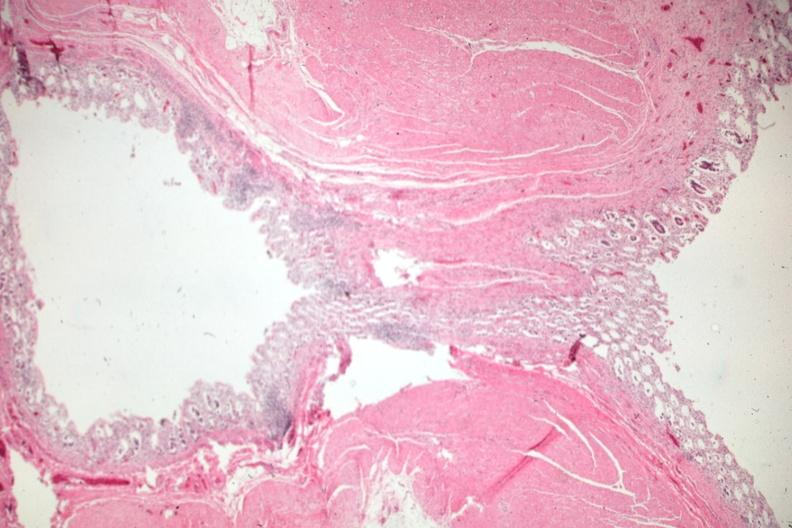does this image show exceptional view of an uncomplicated diverticulum?
Answer the question using a single word or phrase. Yes 